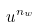<formula> <loc_0><loc_0><loc_500><loc_500>u ^ { n _ { w } }</formula> 